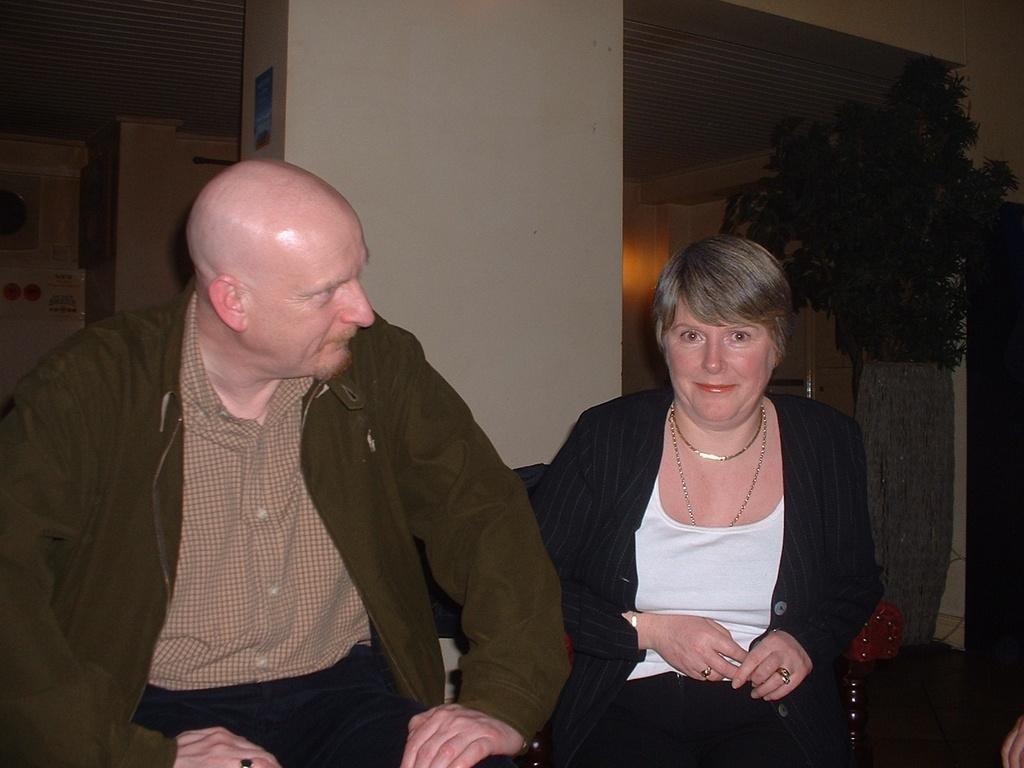How would you summarize this image in a sentence or two? In this picture we can see a woman smiling and a man. In the background we can see pillars, ceiling, leaves, posters and some objects. 